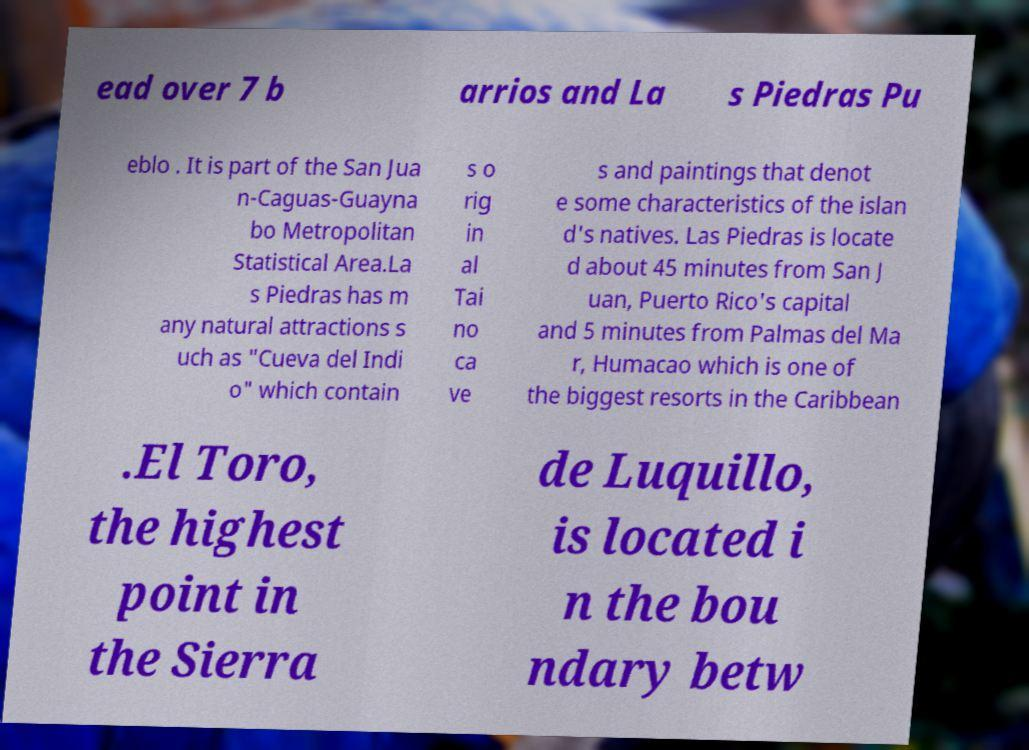Please read and relay the text visible in this image. What does it say? ead over 7 b arrios and La s Piedras Pu eblo . It is part of the San Jua n-Caguas-Guayna bo Metropolitan Statistical Area.La s Piedras has m any natural attractions s uch as "Cueva del Indi o" which contain s o rig in al Tai no ca ve s and paintings that denot e some characteristics of the islan d's natives. Las Piedras is locate d about 45 minutes from San J uan, Puerto Rico's capital and 5 minutes from Palmas del Ma r, Humacao which is one of the biggest resorts in the Caribbean .El Toro, the highest point in the Sierra de Luquillo, is located i n the bou ndary betw 